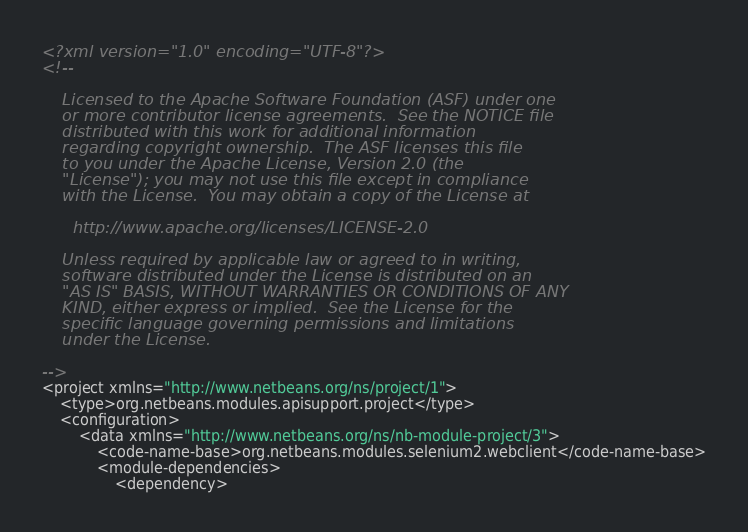<code> <loc_0><loc_0><loc_500><loc_500><_XML_><?xml version="1.0" encoding="UTF-8"?>
<!--

    Licensed to the Apache Software Foundation (ASF) under one
    or more contributor license agreements.  See the NOTICE file
    distributed with this work for additional information
    regarding copyright ownership.  The ASF licenses this file
    to you under the Apache License, Version 2.0 (the
    "License"); you may not use this file except in compliance
    with the License.  You may obtain a copy of the License at

      http://www.apache.org/licenses/LICENSE-2.0

    Unless required by applicable law or agreed to in writing,
    software distributed under the License is distributed on an
    "AS IS" BASIS, WITHOUT WARRANTIES OR CONDITIONS OF ANY
    KIND, either express or implied.  See the License for the
    specific language governing permissions and limitations
    under the License.

-->
<project xmlns="http://www.netbeans.org/ns/project/1">
    <type>org.netbeans.modules.apisupport.project</type>
    <configuration>
        <data xmlns="http://www.netbeans.org/ns/nb-module-project/3">
            <code-name-base>org.netbeans.modules.selenium2.webclient</code-name-base>
            <module-dependencies>
                <dependency></code> 